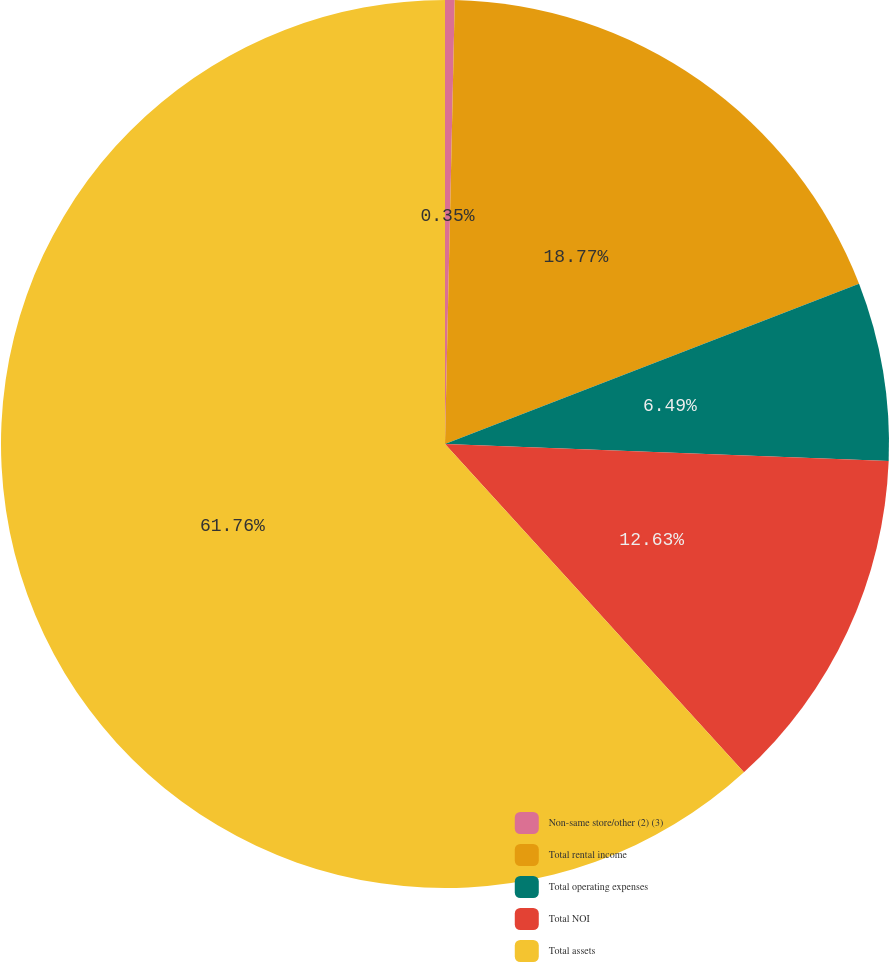Convert chart. <chart><loc_0><loc_0><loc_500><loc_500><pie_chart><fcel>Non-same store/other (2) (3)<fcel>Total rental income<fcel>Total operating expenses<fcel>Total NOI<fcel>Total assets<nl><fcel>0.35%<fcel>18.77%<fcel>6.49%<fcel>12.63%<fcel>61.75%<nl></chart> 